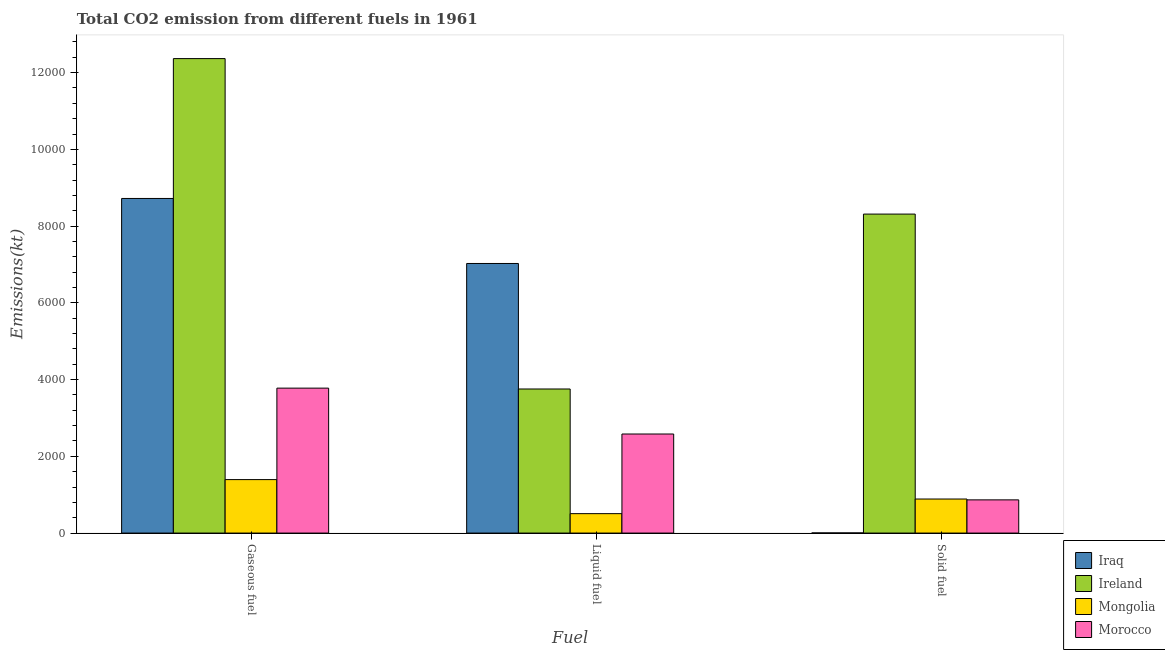How many different coloured bars are there?
Give a very brief answer. 4. How many groups of bars are there?
Make the answer very short. 3. Are the number of bars per tick equal to the number of legend labels?
Make the answer very short. Yes. How many bars are there on the 1st tick from the right?
Your response must be concise. 4. What is the label of the 3rd group of bars from the left?
Your answer should be very brief. Solid fuel. What is the amount of co2 emissions from gaseous fuel in Ireland?
Ensure brevity in your answer.  1.24e+04. Across all countries, what is the maximum amount of co2 emissions from solid fuel?
Give a very brief answer. 8313.09. Across all countries, what is the minimum amount of co2 emissions from liquid fuel?
Give a very brief answer. 506.05. In which country was the amount of co2 emissions from gaseous fuel maximum?
Offer a terse response. Ireland. In which country was the amount of co2 emissions from solid fuel minimum?
Keep it short and to the point. Iraq. What is the total amount of co2 emissions from gaseous fuel in the graph?
Give a very brief answer. 2.63e+04. What is the difference between the amount of co2 emissions from liquid fuel in Iraq and that in Morocco?
Your answer should be compact. 4444.4. What is the difference between the amount of co2 emissions from solid fuel in Ireland and the amount of co2 emissions from liquid fuel in Morocco?
Provide a short and direct response. 5731.52. What is the average amount of co2 emissions from liquid fuel per country?
Keep it short and to the point. 3467.15. What is the difference between the amount of co2 emissions from liquid fuel and amount of co2 emissions from solid fuel in Iraq?
Give a very brief answer. 7022.3. In how many countries, is the amount of co2 emissions from solid fuel greater than 4000 kt?
Provide a succinct answer. 1. What is the ratio of the amount of co2 emissions from gaseous fuel in Mongolia to that in Iraq?
Your answer should be very brief. 0.16. Is the amount of co2 emissions from gaseous fuel in Morocco less than that in Mongolia?
Your answer should be compact. No. Is the difference between the amount of co2 emissions from liquid fuel in Morocco and Ireland greater than the difference between the amount of co2 emissions from solid fuel in Morocco and Ireland?
Ensure brevity in your answer.  Yes. What is the difference between the highest and the second highest amount of co2 emissions from solid fuel?
Offer a very short reply. 7425.68. What is the difference between the highest and the lowest amount of co2 emissions from gaseous fuel?
Ensure brevity in your answer.  1.10e+04. In how many countries, is the amount of co2 emissions from gaseous fuel greater than the average amount of co2 emissions from gaseous fuel taken over all countries?
Your response must be concise. 2. Is the sum of the amount of co2 emissions from gaseous fuel in Ireland and Mongolia greater than the maximum amount of co2 emissions from solid fuel across all countries?
Make the answer very short. Yes. What does the 1st bar from the left in Liquid fuel represents?
Offer a very short reply. Iraq. What does the 4th bar from the right in Liquid fuel represents?
Ensure brevity in your answer.  Iraq. Is it the case that in every country, the sum of the amount of co2 emissions from gaseous fuel and amount of co2 emissions from liquid fuel is greater than the amount of co2 emissions from solid fuel?
Give a very brief answer. Yes. Are all the bars in the graph horizontal?
Your answer should be compact. No. How many countries are there in the graph?
Give a very brief answer. 4. Are the values on the major ticks of Y-axis written in scientific E-notation?
Make the answer very short. No. Does the graph contain any zero values?
Provide a short and direct response. No. How many legend labels are there?
Give a very brief answer. 4. How are the legend labels stacked?
Your answer should be very brief. Vertical. What is the title of the graph?
Provide a succinct answer. Total CO2 emission from different fuels in 1961. What is the label or title of the X-axis?
Give a very brief answer. Fuel. What is the label or title of the Y-axis?
Make the answer very short. Emissions(kt). What is the Emissions(kt) of Iraq in Gaseous fuel?
Keep it short and to the point. 8720.13. What is the Emissions(kt) of Ireland in Gaseous fuel?
Your response must be concise. 1.24e+04. What is the Emissions(kt) in Mongolia in Gaseous fuel?
Provide a short and direct response. 1393.46. What is the Emissions(kt) of Morocco in Gaseous fuel?
Give a very brief answer. 3777.01. What is the Emissions(kt) in Iraq in Liquid fuel?
Make the answer very short. 7025.97. What is the Emissions(kt) of Ireland in Liquid fuel?
Make the answer very short. 3755.01. What is the Emissions(kt) in Mongolia in Liquid fuel?
Offer a very short reply. 506.05. What is the Emissions(kt) of Morocco in Liquid fuel?
Offer a terse response. 2581.57. What is the Emissions(kt) in Iraq in Solid fuel?
Offer a terse response. 3.67. What is the Emissions(kt) of Ireland in Solid fuel?
Provide a succinct answer. 8313.09. What is the Emissions(kt) of Mongolia in Solid fuel?
Your answer should be compact. 887.41. What is the Emissions(kt) of Morocco in Solid fuel?
Your answer should be very brief. 865.41. Across all Fuel, what is the maximum Emissions(kt) of Iraq?
Give a very brief answer. 8720.13. Across all Fuel, what is the maximum Emissions(kt) of Ireland?
Give a very brief answer. 1.24e+04. Across all Fuel, what is the maximum Emissions(kt) in Mongolia?
Keep it short and to the point. 1393.46. Across all Fuel, what is the maximum Emissions(kt) in Morocco?
Your answer should be very brief. 3777.01. Across all Fuel, what is the minimum Emissions(kt) of Iraq?
Make the answer very short. 3.67. Across all Fuel, what is the minimum Emissions(kt) of Ireland?
Ensure brevity in your answer.  3755.01. Across all Fuel, what is the minimum Emissions(kt) of Mongolia?
Keep it short and to the point. 506.05. Across all Fuel, what is the minimum Emissions(kt) of Morocco?
Make the answer very short. 865.41. What is the total Emissions(kt) of Iraq in the graph?
Give a very brief answer. 1.57e+04. What is the total Emissions(kt) in Ireland in the graph?
Your answer should be very brief. 2.44e+04. What is the total Emissions(kt) in Mongolia in the graph?
Provide a short and direct response. 2786.92. What is the total Emissions(kt) in Morocco in the graph?
Provide a succinct answer. 7223.99. What is the difference between the Emissions(kt) of Iraq in Gaseous fuel and that in Liquid fuel?
Your answer should be compact. 1694.15. What is the difference between the Emissions(kt) in Ireland in Gaseous fuel and that in Liquid fuel?
Your answer should be very brief. 8610.12. What is the difference between the Emissions(kt) of Mongolia in Gaseous fuel and that in Liquid fuel?
Offer a terse response. 887.41. What is the difference between the Emissions(kt) in Morocco in Gaseous fuel and that in Liquid fuel?
Provide a short and direct response. 1195.44. What is the difference between the Emissions(kt) in Iraq in Gaseous fuel and that in Solid fuel?
Provide a succinct answer. 8716.46. What is the difference between the Emissions(kt) of Ireland in Gaseous fuel and that in Solid fuel?
Provide a succinct answer. 4052.03. What is the difference between the Emissions(kt) in Mongolia in Gaseous fuel and that in Solid fuel?
Provide a short and direct response. 506.05. What is the difference between the Emissions(kt) in Morocco in Gaseous fuel and that in Solid fuel?
Your answer should be very brief. 2911.6. What is the difference between the Emissions(kt) in Iraq in Liquid fuel and that in Solid fuel?
Give a very brief answer. 7022.31. What is the difference between the Emissions(kt) in Ireland in Liquid fuel and that in Solid fuel?
Provide a short and direct response. -4558.08. What is the difference between the Emissions(kt) in Mongolia in Liquid fuel and that in Solid fuel?
Your answer should be compact. -381.37. What is the difference between the Emissions(kt) in Morocco in Liquid fuel and that in Solid fuel?
Ensure brevity in your answer.  1716.16. What is the difference between the Emissions(kt) in Iraq in Gaseous fuel and the Emissions(kt) in Ireland in Liquid fuel?
Offer a very short reply. 4965.12. What is the difference between the Emissions(kt) in Iraq in Gaseous fuel and the Emissions(kt) in Mongolia in Liquid fuel?
Give a very brief answer. 8214.08. What is the difference between the Emissions(kt) of Iraq in Gaseous fuel and the Emissions(kt) of Morocco in Liquid fuel?
Your answer should be compact. 6138.56. What is the difference between the Emissions(kt) in Ireland in Gaseous fuel and the Emissions(kt) in Mongolia in Liquid fuel?
Provide a short and direct response. 1.19e+04. What is the difference between the Emissions(kt) of Ireland in Gaseous fuel and the Emissions(kt) of Morocco in Liquid fuel?
Offer a terse response. 9783.56. What is the difference between the Emissions(kt) of Mongolia in Gaseous fuel and the Emissions(kt) of Morocco in Liquid fuel?
Ensure brevity in your answer.  -1188.11. What is the difference between the Emissions(kt) of Iraq in Gaseous fuel and the Emissions(kt) of Ireland in Solid fuel?
Make the answer very short. 407.04. What is the difference between the Emissions(kt) of Iraq in Gaseous fuel and the Emissions(kt) of Mongolia in Solid fuel?
Your response must be concise. 7832.71. What is the difference between the Emissions(kt) of Iraq in Gaseous fuel and the Emissions(kt) of Morocco in Solid fuel?
Offer a very short reply. 7854.71. What is the difference between the Emissions(kt) of Ireland in Gaseous fuel and the Emissions(kt) of Mongolia in Solid fuel?
Ensure brevity in your answer.  1.15e+04. What is the difference between the Emissions(kt) in Ireland in Gaseous fuel and the Emissions(kt) in Morocco in Solid fuel?
Your response must be concise. 1.15e+04. What is the difference between the Emissions(kt) of Mongolia in Gaseous fuel and the Emissions(kt) of Morocco in Solid fuel?
Ensure brevity in your answer.  528.05. What is the difference between the Emissions(kt) in Iraq in Liquid fuel and the Emissions(kt) in Ireland in Solid fuel?
Give a very brief answer. -1287.12. What is the difference between the Emissions(kt) in Iraq in Liquid fuel and the Emissions(kt) in Mongolia in Solid fuel?
Keep it short and to the point. 6138.56. What is the difference between the Emissions(kt) of Iraq in Liquid fuel and the Emissions(kt) of Morocco in Solid fuel?
Keep it short and to the point. 6160.56. What is the difference between the Emissions(kt) of Ireland in Liquid fuel and the Emissions(kt) of Mongolia in Solid fuel?
Give a very brief answer. 2867.59. What is the difference between the Emissions(kt) of Ireland in Liquid fuel and the Emissions(kt) of Morocco in Solid fuel?
Provide a short and direct response. 2889.6. What is the difference between the Emissions(kt) in Mongolia in Liquid fuel and the Emissions(kt) in Morocco in Solid fuel?
Provide a short and direct response. -359.37. What is the average Emissions(kt) of Iraq per Fuel?
Your answer should be compact. 5249.92. What is the average Emissions(kt) of Ireland per Fuel?
Make the answer very short. 8144.41. What is the average Emissions(kt) in Mongolia per Fuel?
Your response must be concise. 928.97. What is the average Emissions(kt) of Morocco per Fuel?
Provide a succinct answer. 2408. What is the difference between the Emissions(kt) of Iraq and Emissions(kt) of Ireland in Gaseous fuel?
Offer a terse response. -3645. What is the difference between the Emissions(kt) in Iraq and Emissions(kt) in Mongolia in Gaseous fuel?
Give a very brief answer. 7326.67. What is the difference between the Emissions(kt) in Iraq and Emissions(kt) in Morocco in Gaseous fuel?
Give a very brief answer. 4943.12. What is the difference between the Emissions(kt) in Ireland and Emissions(kt) in Mongolia in Gaseous fuel?
Ensure brevity in your answer.  1.10e+04. What is the difference between the Emissions(kt) of Ireland and Emissions(kt) of Morocco in Gaseous fuel?
Keep it short and to the point. 8588.11. What is the difference between the Emissions(kt) of Mongolia and Emissions(kt) of Morocco in Gaseous fuel?
Offer a terse response. -2383.55. What is the difference between the Emissions(kt) of Iraq and Emissions(kt) of Ireland in Liquid fuel?
Your answer should be compact. 3270.96. What is the difference between the Emissions(kt) in Iraq and Emissions(kt) in Mongolia in Liquid fuel?
Offer a terse response. 6519.93. What is the difference between the Emissions(kt) in Iraq and Emissions(kt) in Morocco in Liquid fuel?
Offer a very short reply. 4444.4. What is the difference between the Emissions(kt) of Ireland and Emissions(kt) of Mongolia in Liquid fuel?
Your answer should be compact. 3248.96. What is the difference between the Emissions(kt) of Ireland and Emissions(kt) of Morocco in Liquid fuel?
Your response must be concise. 1173.44. What is the difference between the Emissions(kt) of Mongolia and Emissions(kt) of Morocco in Liquid fuel?
Keep it short and to the point. -2075.52. What is the difference between the Emissions(kt) in Iraq and Emissions(kt) in Ireland in Solid fuel?
Offer a very short reply. -8309.42. What is the difference between the Emissions(kt) of Iraq and Emissions(kt) of Mongolia in Solid fuel?
Your answer should be compact. -883.75. What is the difference between the Emissions(kt) of Iraq and Emissions(kt) of Morocco in Solid fuel?
Your answer should be compact. -861.75. What is the difference between the Emissions(kt) of Ireland and Emissions(kt) of Mongolia in Solid fuel?
Your response must be concise. 7425.68. What is the difference between the Emissions(kt) of Ireland and Emissions(kt) of Morocco in Solid fuel?
Your answer should be very brief. 7447.68. What is the difference between the Emissions(kt) in Mongolia and Emissions(kt) in Morocco in Solid fuel?
Provide a short and direct response. 22. What is the ratio of the Emissions(kt) of Iraq in Gaseous fuel to that in Liquid fuel?
Provide a succinct answer. 1.24. What is the ratio of the Emissions(kt) of Ireland in Gaseous fuel to that in Liquid fuel?
Offer a terse response. 3.29. What is the ratio of the Emissions(kt) of Mongolia in Gaseous fuel to that in Liquid fuel?
Provide a short and direct response. 2.75. What is the ratio of the Emissions(kt) of Morocco in Gaseous fuel to that in Liquid fuel?
Your answer should be compact. 1.46. What is the ratio of the Emissions(kt) in Iraq in Gaseous fuel to that in Solid fuel?
Your answer should be very brief. 2378. What is the ratio of the Emissions(kt) in Ireland in Gaseous fuel to that in Solid fuel?
Offer a very short reply. 1.49. What is the ratio of the Emissions(kt) in Mongolia in Gaseous fuel to that in Solid fuel?
Provide a short and direct response. 1.57. What is the ratio of the Emissions(kt) of Morocco in Gaseous fuel to that in Solid fuel?
Make the answer very short. 4.36. What is the ratio of the Emissions(kt) in Iraq in Liquid fuel to that in Solid fuel?
Keep it short and to the point. 1916. What is the ratio of the Emissions(kt) of Ireland in Liquid fuel to that in Solid fuel?
Provide a short and direct response. 0.45. What is the ratio of the Emissions(kt) of Mongolia in Liquid fuel to that in Solid fuel?
Ensure brevity in your answer.  0.57. What is the ratio of the Emissions(kt) in Morocco in Liquid fuel to that in Solid fuel?
Provide a succinct answer. 2.98. What is the difference between the highest and the second highest Emissions(kt) of Iraq?
Your answer should be very brief. 1694.15. What is the difference between the highest and the second highest Emissions(kt) of Ireland?
Your answer should be compact. 4052.03. What is the difference between the highest and the second highest Emissions(kt) of Mongolia?
Keep it short and to the point. 506.05. What is the difference between the highest and the second highest Emissions(kt) of Morocco?
Make the answer very short. 1195.44. What is the difference between the highest and the lowest Emissions(kt) in Iraq?
Your response must be concise. 8716.46. What is the difference between the highest and the lowest Emissions(kt) of Ireland?
Offer a very short reply. 8610.12. What is the difference between the highest and the lowest Emissions(kt) of Mongolia?
Provide a short and direct response. 887.41. What is the difference between the highest and the lowest Emissions(kt) in Morocco?
Your response must be concise. 2911.6. 